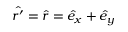Convert formula to latex. <formula><loc_0><loc_0><loc_500><loc_500>\hat { r ^ { \prime } } = \hat { r } = \hat { e } _ { x } + \hat { e } _ { y }</formula> 